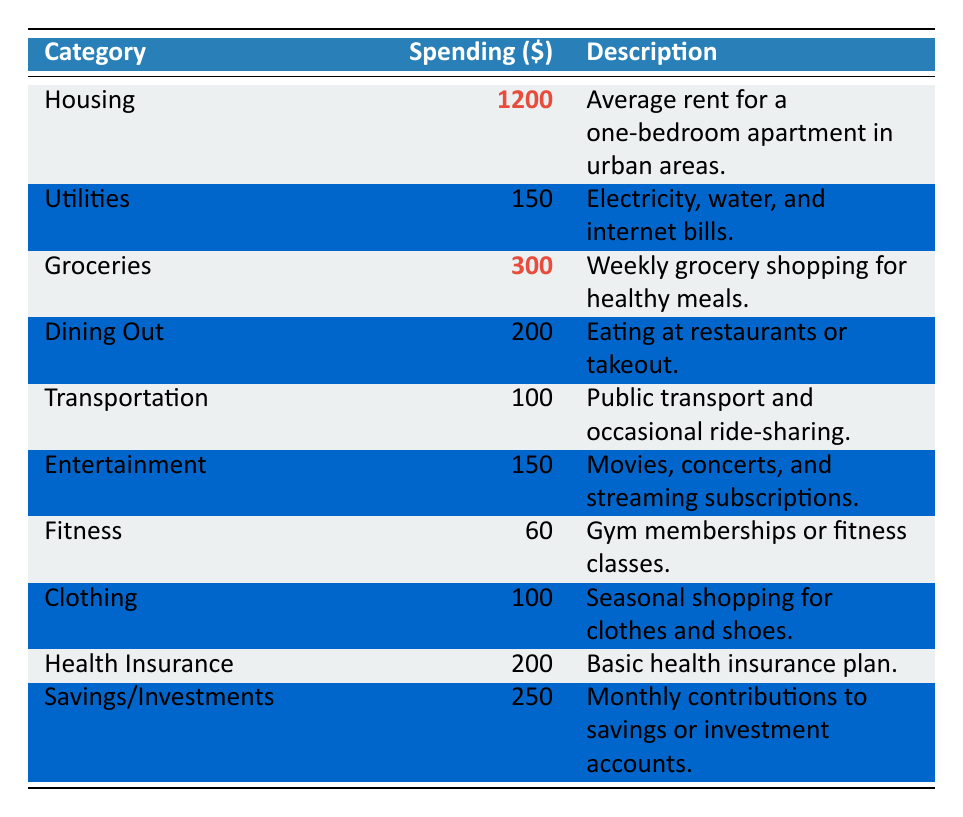What is the highest spending category? By looking at the table, I see that the category labeled "Housing" has the highest spending of $1200, which is more than any other category listed.
Answer: Housing What is the total spending on groceries and dining out? Groceries are $300 and dining out is $200. Adding these together gives $300 + $200 = $500 as the total spending for both categories.
Answer: 500 Is the spending on transportation less than the spending on fitness? Transportation spending is $100 and fitness spending is $60. Since $100 is greater than $60, the statement is false.
Answer: No How much more is spent on housing compared to utilities? Housing costs $1200 and utilities costs $150. The difference is $1200 - $150 = $1050, indicating that housing spending is $1050 more than utilities.
Answer: 1050 What is the total amount spent on savings/investments and health insurance combined? The spending on savings/investments is $250 and on health insurance is $200. Adding these amounts gives $250 + $200 = $450 for the total spending in these two categories.
Answer: 450 Which category has the lowest spending? The fitness category has a spending amount of $60, which is less than any other category listed in the table.
Answer: Fitness If a young adult wants to minimize their monthly spending, which categories could they reduce? The categories with the lowest spending are fitness at $60 and clothing at $100. Reducing these two would lead to lower overall spending.
Answer: Fitness and Clothing What is the average spending across all categories? To find the average, I need to sum all spending values: $1200 + $150 + $300 + $200 + $100 + $150 + $60 + $100 + $200 + $250 = $2210. Since there are 10 categories, I divide by 10: $2210 / 10 = $221.
Answer: 221 How much is spent on entertainment compared to transportation? Entertainment spending is $150, while transportation is $100. When comparing these amounts, $150 is greater than $100, meaning entertainment spending is higher.
Answer: Entertainment is higher Which category represents a spending greater than $200 but less than $300? By reviewing the spending amounts, savings/investments at $250 fits this range, as it is greater than $200 and less than $300.
Answer: Savings/Investments 